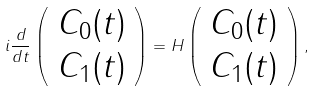Convert formula to latex. <formula><loc_0><loc_0><loc_500><loc_500>i \frac { d } { d t } \left ( \begin{array} { c } C _ { 0 } ( t ) \\ C _ { 1 } ( t ) \end{array} \right ) = H \left ( \begin{array} { c } C _ { 0 } ( t ) \\ C _ { 1 } ( t ) \end{array} \right ) ,</formula> 